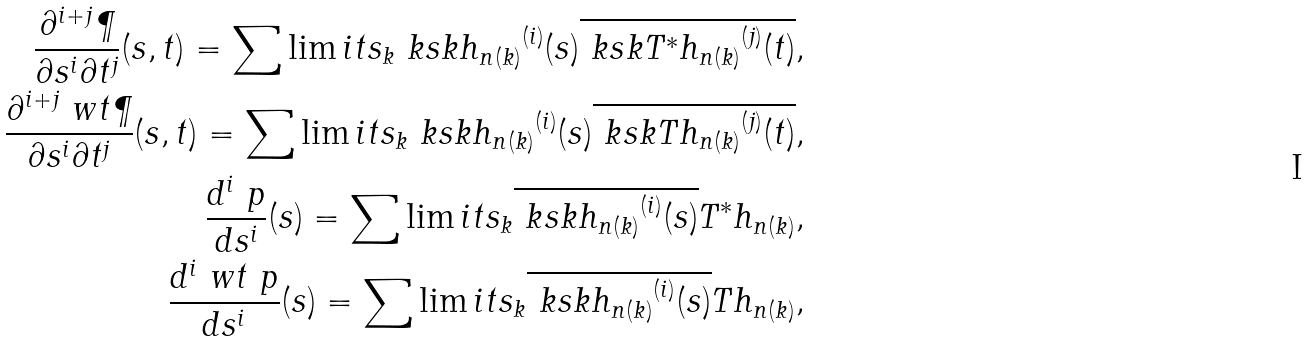Convert formula to latex. <formula><loc_0><loc_0><loc_500><loc_500>\frac { \partial ^ { i + j } \P } { \partial s ^ { i } \partial t ^ { j } } ( s , t ) = \sum \lim i t s _ { k } \ k s k { h _ { n ( k ) } } ^ { ( i ) } ( s ) \overline { \ k s k { T ^ { * } h _ { n ( k ) } } ^ { ( j ) } ( t ) } , \\ \frac { \partial ^ { i + j } \ w t \P } { \partial s ^ { i } \partial t ^ { j } } ( s , t ) = \sum \lim i t s _ { k } \ k s k { h _ { n ( k ) } } ^ { ( i ) } ( s ) \overline { \ k s k { T h _ { n ( k ) } } ^ { ( j ) } ( t ) } , \\ \frac { d ^ { i } \ p } { d s ^ { i } } ( s ) = \sum \lim i t s _ { k } \overline { \ k s k { h _ { n ( k ) } } ^ { ( i ) } ( s ) } T ^ { * } h _ { n ( k ) } , \\ \frac { d ^ { i } \ w t \ p } { d s ^ { i } } ( s ) = \sum \lim i t s _ { k } \overline { \ k s k { h _ { n ( k ) } } ^ { ( i ) } ( s ) } T h _ { n ( k ) } ,</formula> 